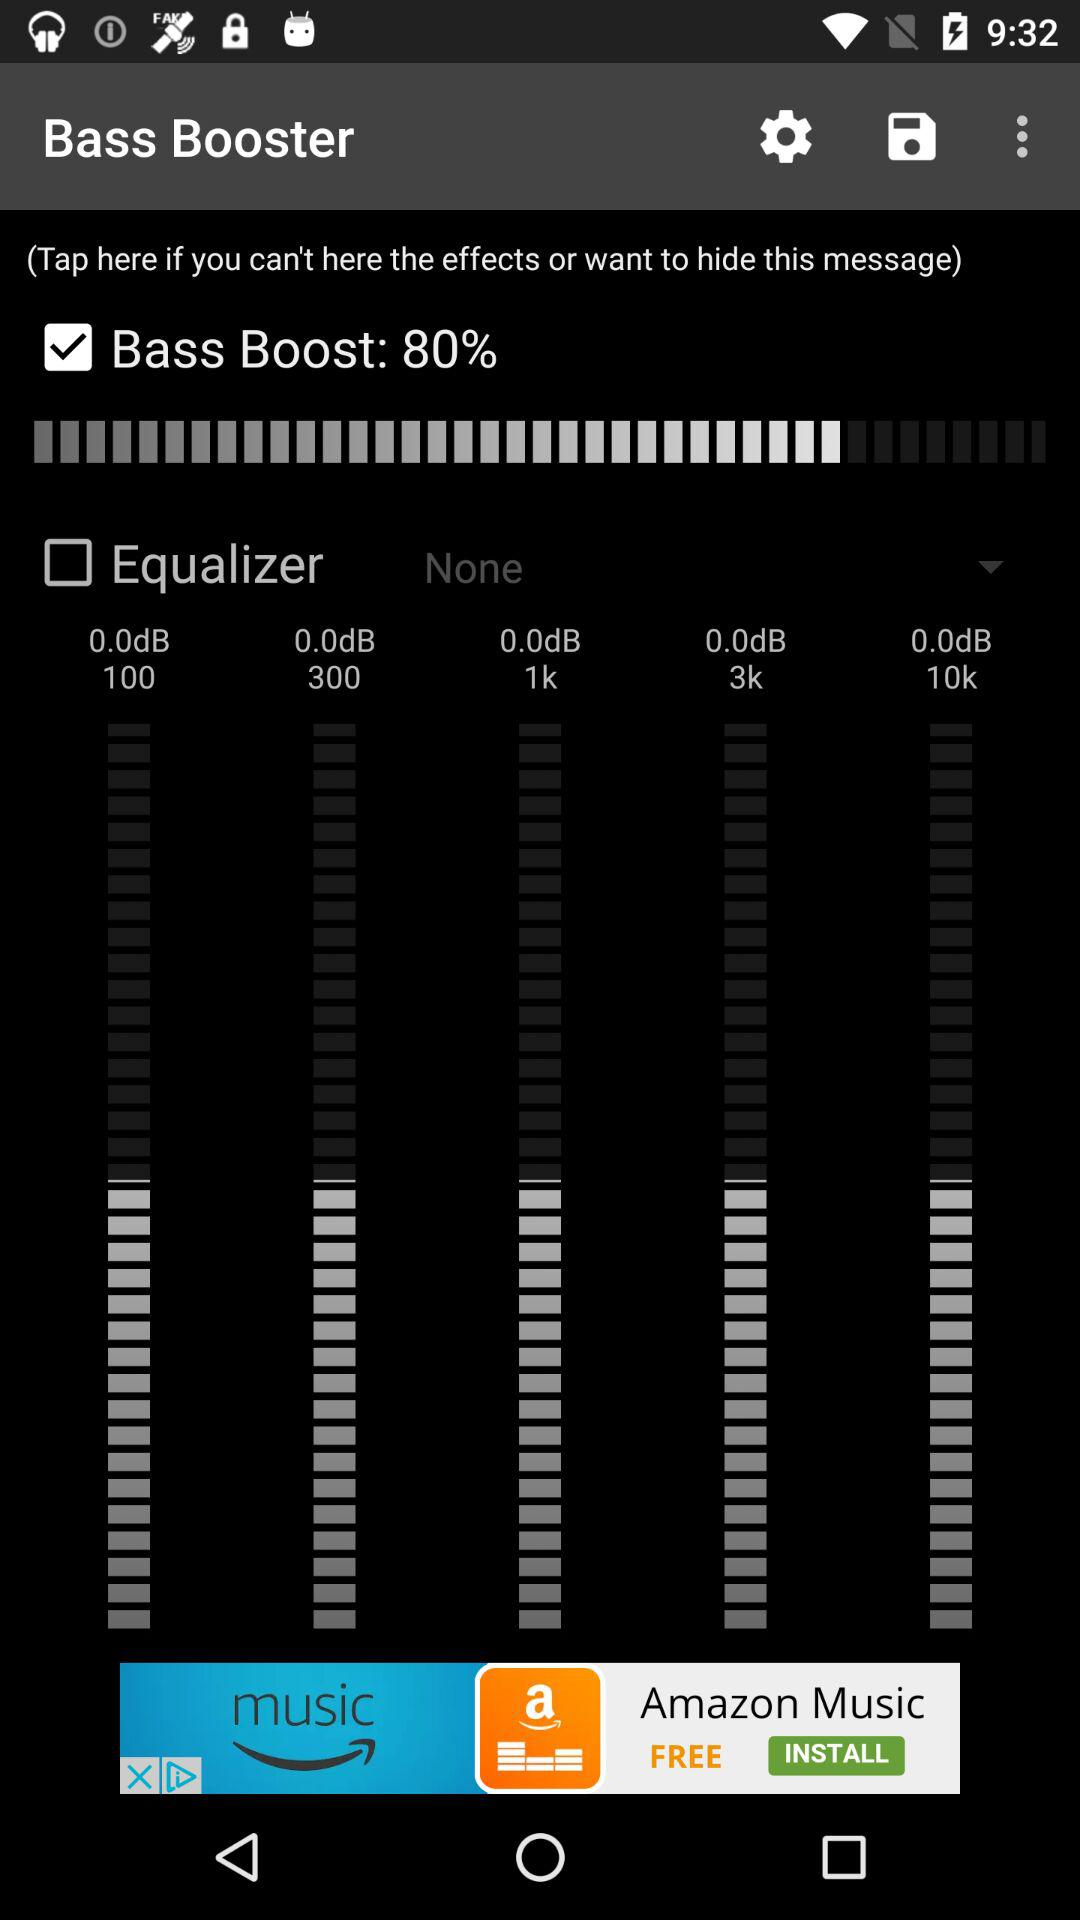What is the percentage of "Bass Boost"? The "Bass Boost" is at 80%. 